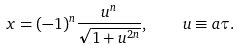<formula> <loc_0><loc_0><loc_500><loc_500>x = ( - 1 ) ^ { n } \frac { u ^ { n } } { \sqrt { 1 + u ^ { 2 n } } } , \quad u \equiv a \tau .</formula> 